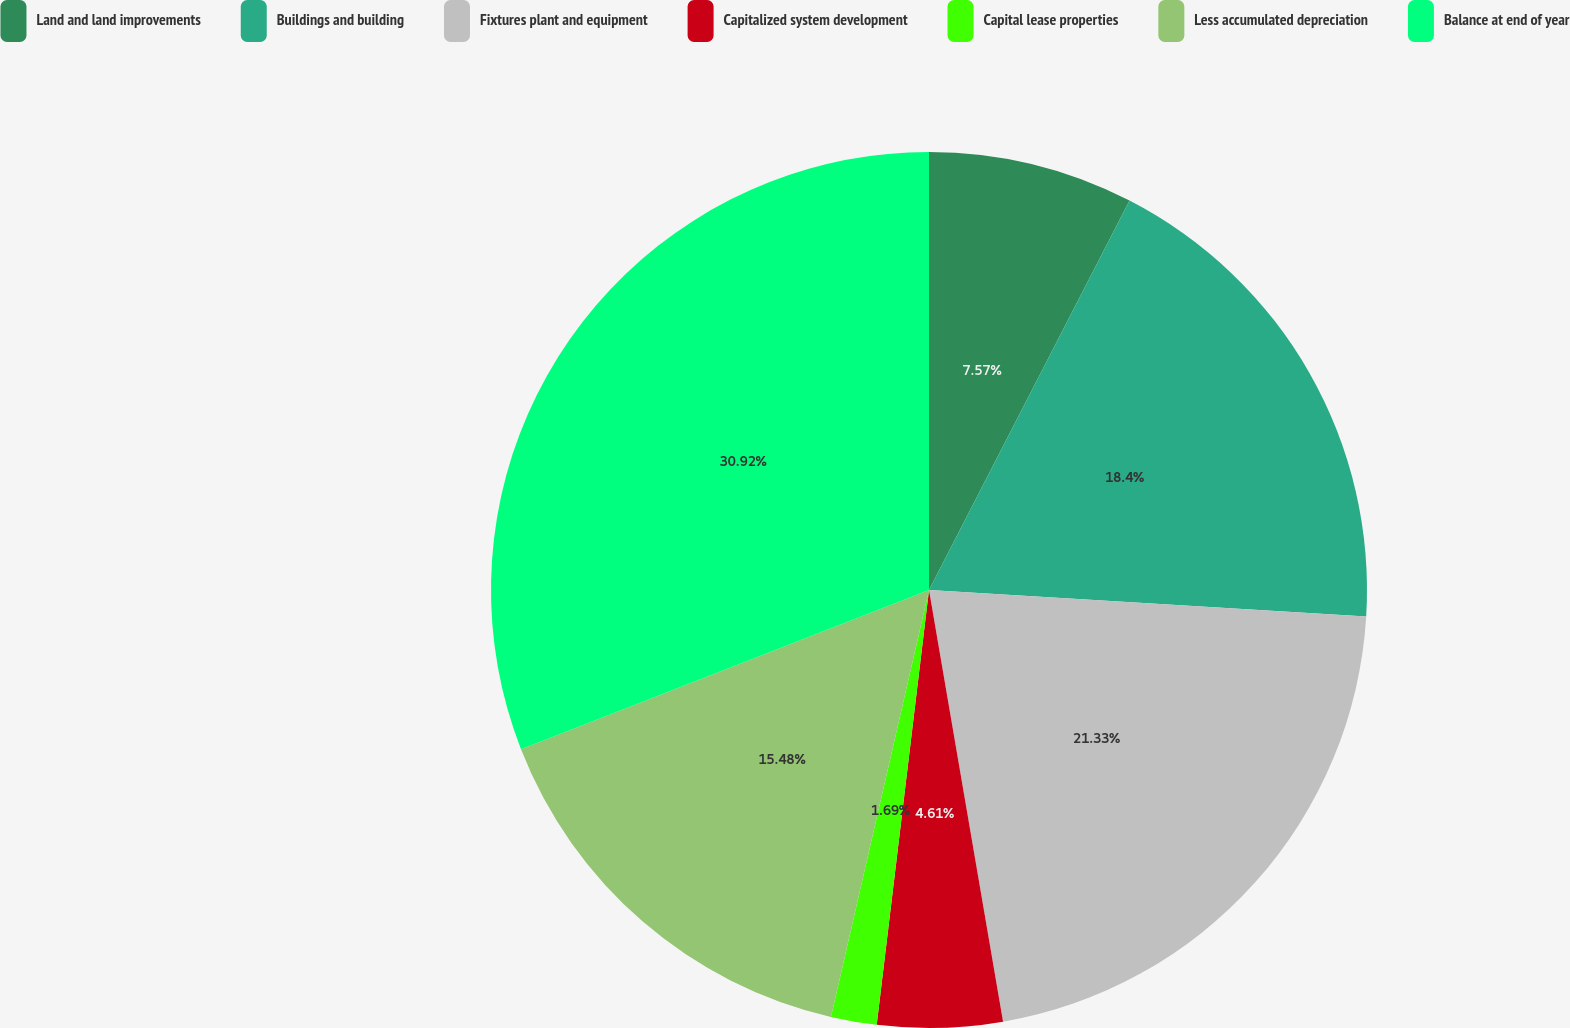Convert chart to OTSL. <chart><loc_0><loc_0><loc_500><loc_500><pie_chart><fcel>Land and land improvements<fcel>Buildings and building<fcel>Fixtures plant and equipment<fcel>Capitalized system development<fcel>Capital lease properties<fcel>Less accumulated depreciation<fcel>Balance at end of year<nl><fcel>7.57%<fcel>18.4%<fcel>21.33%<fcel>4.61%<fcel>1.69%<fcel>15.48%<fcel>30.93%<nl></chart> 